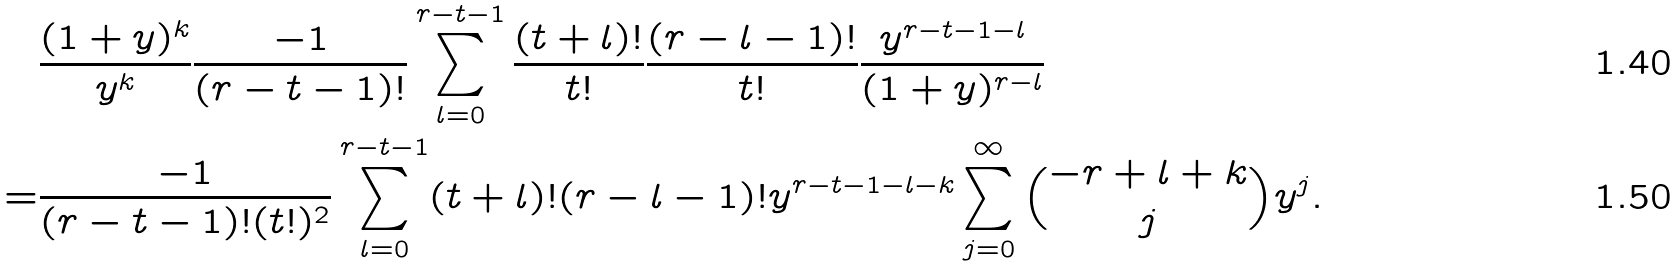Convert formula to latex. <formula><loc_0><loc_0><loc_500><loc_500>& \frac { ( 1 + y ) ^ { k } } { y ^ { k } } \frac { - 1 } { ( r - t - 1 ) ! } \sum _ { l = 0 } ^ { r - t - 1 } \frac { ( t + l ) ! } { t ! } \frac { ( r - l - 1 ) ! } { t ! } \frac { y ^ { r - t - 1 - l } } { ( 1 + y ) ^ { r - l } } \\ = & \frac { - 1 } { ( r - t - 1 ) ! ( t ! ) ^ { 2 } } \sum _ { l = 0 } ^ { r - t - 1 } ( t + l ) ! ( r - l - 1 ) ! y ^ { r - t - 1 - l - k } \sum _ { j = 0 } ^ { \infty } \binom { - r + l + k } { j } y ^ { j } .</formula> 